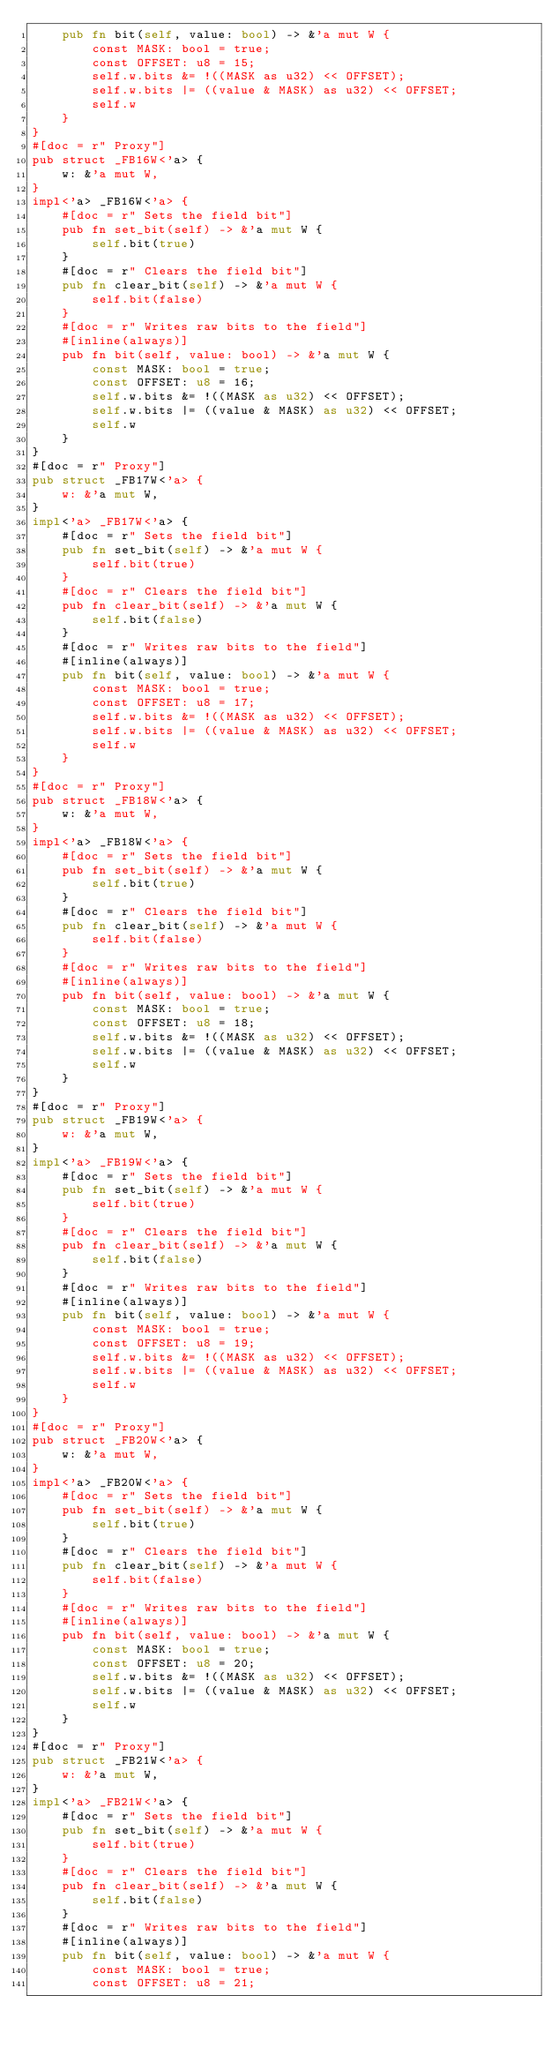Convert code to text. <code><loc_0><loc_0><loc_500><loc_500><_Rust_>    pub fn bit(self, value: bool) -> &'a mut W {
        const MASK: bool = true;
        const OFFSET: u8 = 15;
        self.w.bits &= !((MASK as u32) << OFFSET);
        self.w.bits |= ((value & MASK) as u32) << OFFSET;
        self.w
    }
}
#[doc = r" Proxy"]
pub struct _FB16W<'a> {
    w: &'a mut W,
}
impl<'a> _FB16W<'a> {
    #[doc = r" Sets the field bit"]
    pub fn set_bit(self) -> &'a mut W {
        self.bit(true)
    }
    #[doc = r" Clears the field bit"]
    pub fn clear_bit(self) -> &'a mut W {
        self.bit(false)
    }
    #[doc = r" Writes raw bits to the field"]
    #[inline(always)]
    pub fn bit(self, value: bool) -> &'a mut W {
        const MASK: bool = true;
        const OFFSET: u8 = 16;
        self.w.bits &= !((MASK as u32) << OFFSET);
        self.w.bits |= ((value & MASK) as u32) << OFFSET;
        self.w
    }
}
#[doc = r" Proxy"]
pub struct _FB17W<'a> {
    w: &'a mut W,
}
impl<'a> _FB17W<'a> {
    #[doc = r" Sets the field bit"]
    pub fn set_bit(self) -> &'a mut W {
        self.bit(true)
    }
    #[doc = r" Clears the field bit"]
    pub fn clear_bit(self) -> &'a mut W {
        self.bit(false)
    }
    #[doc = r" Writes raw bits to the field"]
    #[inline(always)]
    pub fn bit(self, value: bool) -> &'a mut W {
        const MASK: bool = true;
        const OFFSET: u8 = 17;
        self.w.bits &= !((MASK as u32) << OFFSET);
        self.w.bits |= ((value & MASK) as u32) << OFFSET;
        self.w
    }
}
#[doc = r" Proxy"]
pub struct _FB18W<'a> {
    w: &'a mut W,
}
impl<'a> _FB18W<'a> {
    #[doc = r" Sets the field bit"]
    pub fn set_bit(self) -> &'a mut W {
        self.bit(true)
    }
    #[doc = r" Clears the field bit"]
    pub fn clear_bit(self) -> &'a mut W {
        self.bit(false)
    }
    #[doc = r" Writes raw bits to the field"]
    #[inline(always)]
    pub fn bit(self, value: bool) -> &'a mut W {
        const MASK: bool = true;
        const OFFSET: u8 = 18;
        self.w.bits &= !((MASK as u32) << OFFSET);
        self.w.bits |= ((value & MASK) as u32) << OFFSET;
        self.w
    }
}
#[doc = r" Proxy"]
pub struct _FB19W<'a> {
    w: &'a mut W,
}
impl<'a> _FB19W<'a> {
    #[doc = r" Sets the field bit"]
    pub fn set_bit(self) -> &'a mut W {
        self.bit(true)
    }
    #[doc = r" Clears the field bit"]
    pub fn clear_bit(self) -> &'a mut W {
        self.bit(false)
    }
    #[doc = r" Writes raw bits to the field"]
    #[inline(always)]
    pub fn bit(self, value: bool) -> &'a mut W {
        const MASK: bool = true;
        const OFFSET: u8 = 19;
        self.w.bits &= !((MASK as u32) << OFFSET);
        self.w.bits |= ((value & MASK) as u32) << OFFSET;
        self.w
    }
}
#[doc = r" Proxy"]
pub struct _FB20W<'a> {
    w: &'a mut W,
}
impl<'a> _FB20W<'a> {
    #[doc = r" Sets the field bit"]
    pub fn set_bit(self) -> &'a mut W {
        self.bit(true)
    }
    #[doc = r" Clears the field bit"]
    pub fn clear_bit(self) -> &'a mut W {
        self.bit(false)
    }
    #[doc = r" Writes raw bits to the field"]
    #[inline(always)]
    pub fn bit(self, value: bool) -> &'a mut W {
        const MASK: bool = true;
        const OFFSET: u8 = 20;
        self.w.bits &= !((MASK as u32) << OFFSET);
        self.w.bits |= ((value & MASK) as u32) << OFFSET;
        self.w
    }
}
#[doc = r" Proxy"]
pub struct _FB21W<'a> {
    w: &'a mut W,
}
impl<'a> _FB21W<'a> {
    #[doc = r" Sets the field bit"]
    pub fn set_bit(self) -> &'a mut W {
        self.bit(true)
    }
    #[doc = r" Clears the field bit"]
    pub fn clear_bit(self) -> &'a mut W {
        self.bit(false)
    }
    #[doc = r" Writes raw bits to the field"]
    #[inline(always)]
    pub fn bit(self, value: bool) -> &'a mut W {
        const MASK: bool = true;
        const OFFSET: u8 = 21;</code> 